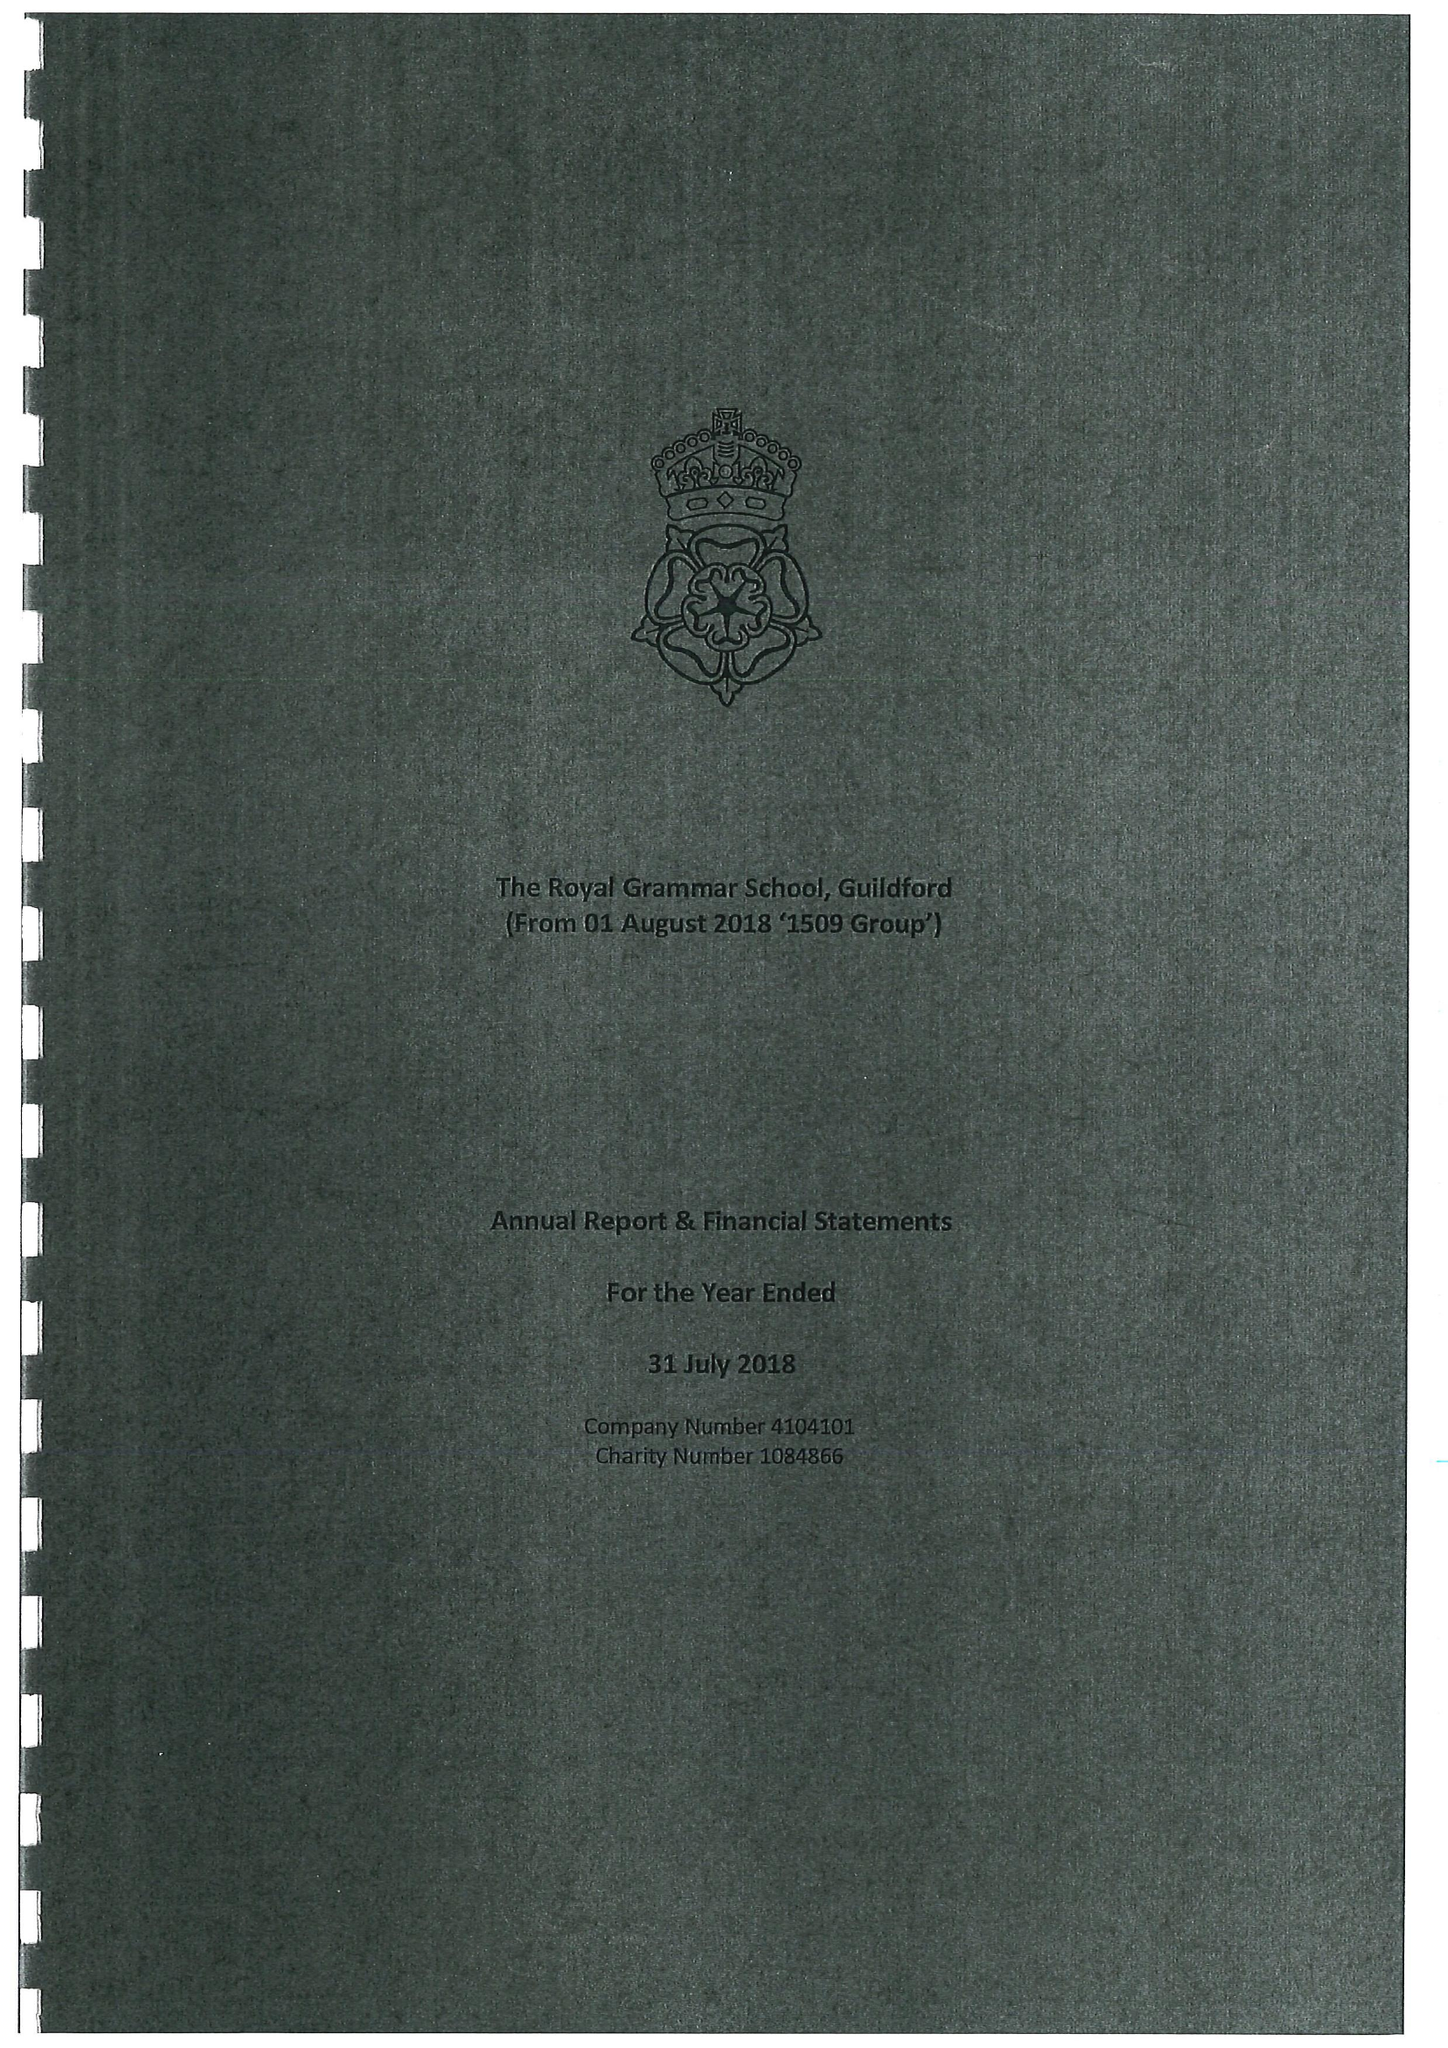What is the value for the address__postcode?
Answer the question using a single word or phrase. GU1 3BB 